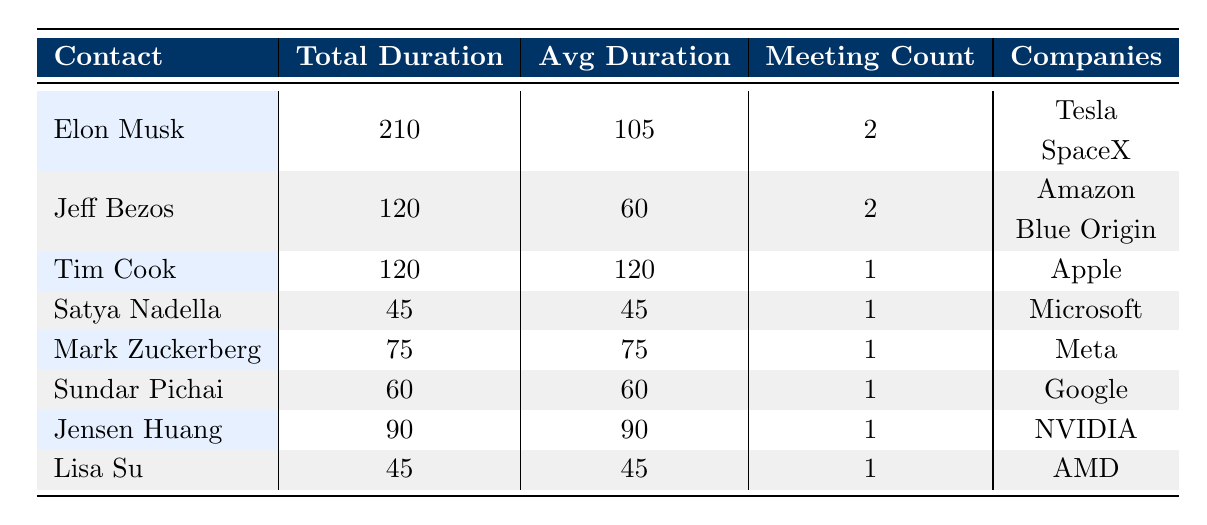What is the total duration of meetings held with Tim Cook? From the table, we see that Tim Cook has one meeting with a total duration of 120 minutes.
Answer: 120 How many meetings did Elon Musk have? The table shows that Elon Musk had two meetings, as indicated by the meeting count column where it lists 2 for him.
Answer: 2 What is the average duration of meetings with Jeff Bezos? Jeff Bezos has two meetings with a total duration of 120 minutes. To find the average, divide the total duration by the meeting count, giving us 120/2 = 60 minutes.
Answer: 60 Did Mark Zuckerberg have more than one meeting? The table indicates that Mark Zuckerberg had only one meeting as the meeting count for him is listed as 1.
Answer: No Which contact had the highest average duration of meetings? By reviewing the table, Tim Cook has the highest average duration of meetings listed as 120 minutes because he had only one meeting, and its duration was also 120 minutes.
Answer: Tim Cook How much total meeting time did high-security level meetings account for? They are with Elon Musk (210 minutes), Tim Cook (120 minutes), Mark Zuckerberg (75 minutes), Jensen Huang (90 minutes), and Elon Musk again (120 minutes), totaling 615 minutes. Sum: 210 + 120 + 75 + 90 + 120 = 615 minutes.
Answer: 615 Is there a contact who had meetings with two different companies? By examining the data, only Elon Musk had meetings with two different companies (Tesla and SpaceX).
Answer: Yes How many companies were involved in the meetings? To find the total number of unique companies, we list them: Tesla, Amazon, Apple, Microsoft, Meta, Google, NVIDIA, and AMD, giving us a total of 8 companies.
Answer: 8 What is the duration difference between the longest and shortest meetings? The longest meeting duration is 120 minutes (Elon Musk - SpaceX and Tim Cook) and the shortest is 45 minutes (Satya Nadella and Lisa Su). The difference is 120 - 45 = 75 minutes.
Answer: 75 What is the total duration of meetings with contacts from the technology sector? The contacts from the technology sector are Tim Cook (120 minutes), Satya Nadella (45 minutes), Mark Zuckerberg (75 minutes), Sundar Pichai (60 minutes), and Jensen Huang (90 minutes), totaling 390 minutes. Adding these: 120 + 45 + 75 + 60 + 90 = 390 minutes.
Answer: 390 